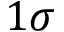<formula> <loc_0><loc_0><loc_500><loc_500>1 \sigma</formula> 